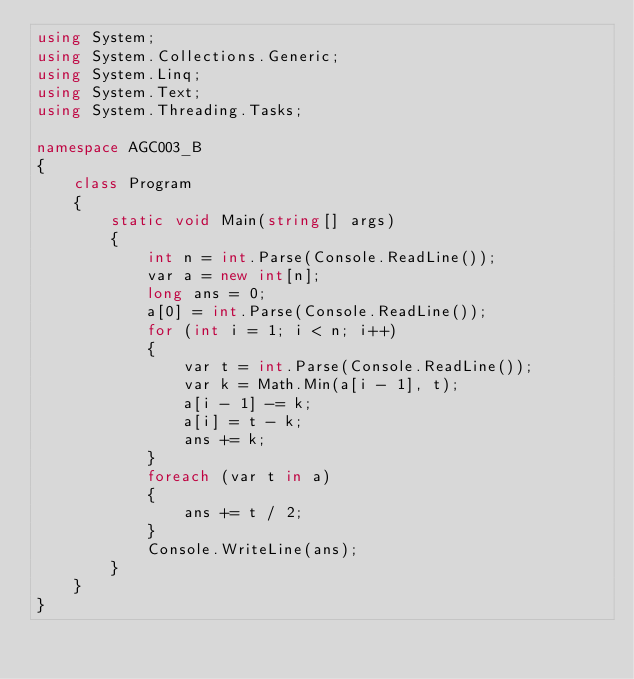Convert code to text. <code><loc_0><loc_0><loc_500><loc_500><_C#_>using System;
using System.Collections.Generic;
using System.Linq;
using System.Text;
using System.Threading.Tasks;

namespace AGC003_B
{
    class Program
    {
        static void Main(string[] args)
        {
            int n = int.Parse(Console.ReadLine());
            var a = new int[n];
            long ans = 0;
            a[0] = int.Parse(Console.ReadLine());
            for (int i = 1; i < n; i++)
            {
                var t = int.Parse(Console.ReadLine());
                var k = Math.Min(a[i - 1], t);
                a[i - 1] -= k;
                a[i] = t - k;
                ans += k;
            }
            foreach (var t in a)
            {
                ans += t / 2;
            }
            Console.WriteLine(ans);
        }
    }
}
</code> 